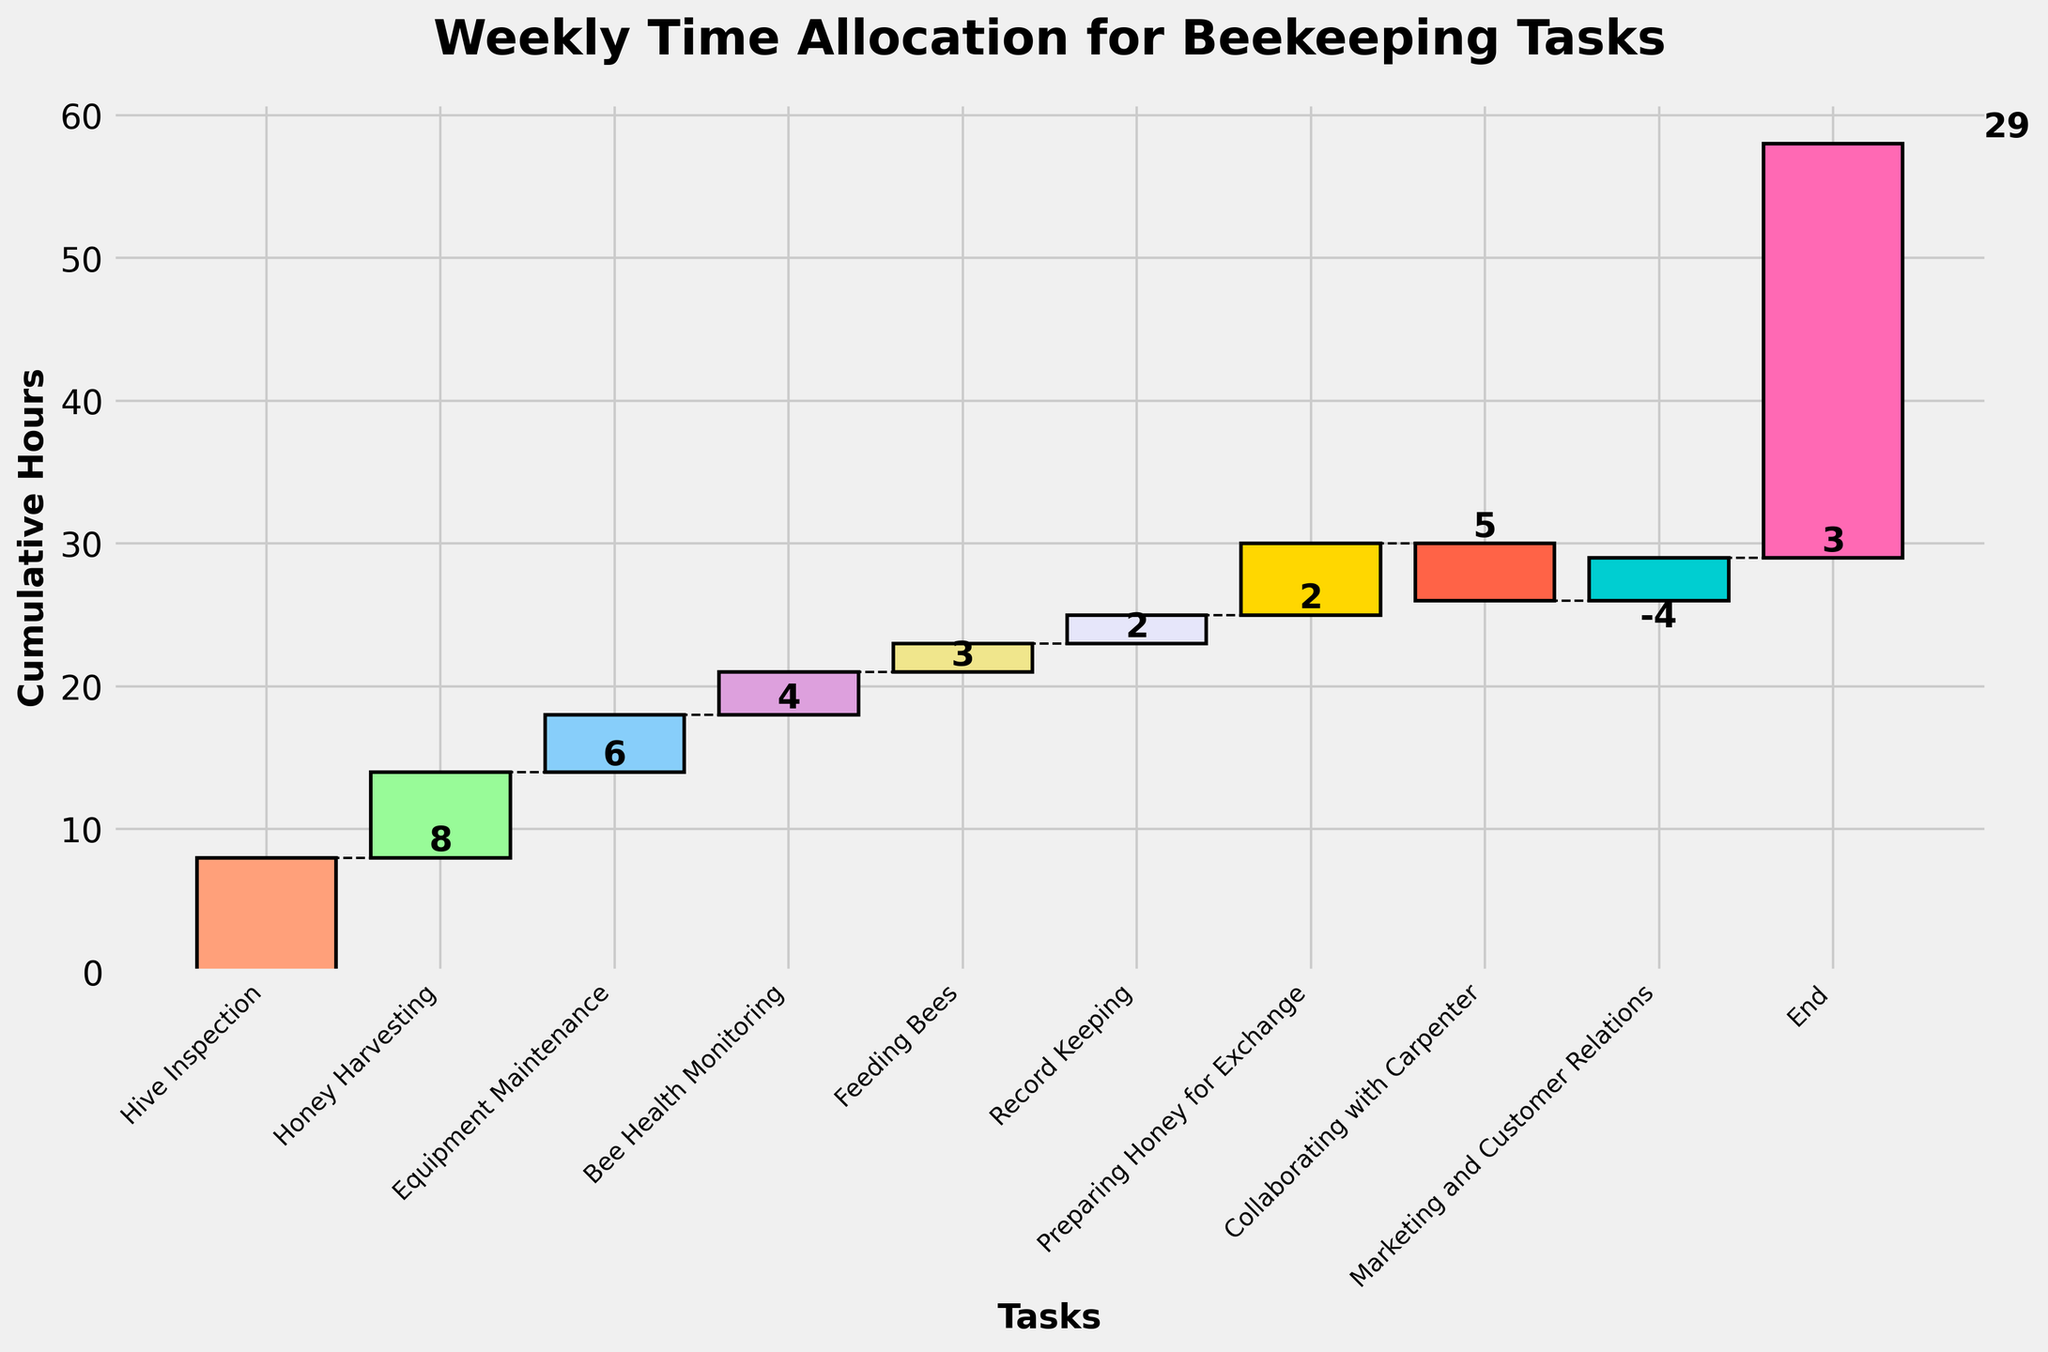What is the title of the chart? The chart's title is prominently displayed at the top of the figure. It is usually formatted in bold and large font.
Answer: Weekly Time Allocation for Beekeeping Tasks How many tasks are listed in the chart? Count the number of unique tasks along the x-axis. Each task represents a data point or category.
Answer: 10 What is the cumulative number of hours spent after Equipment Maintenance? Identify the cumulative hours after the Equipment Maintenance task from the figure. In this case, it involves summing up the hours from Start, Hive Inspection, Honey Harvesting, and Equipment Maintenance.
Answer: 18 Which task has the highest positive number of hours allocated? Look for the task with the highest bar going upward from the previous cumulative total. Compare all upward bars to find the maximum value.
Answer: Hive Inspection How much time is spent collaborating with the carpenter, and what's its impact on the cumulative hours? Identify the specific bar for Collaborating with Carpenter from the x-axis. Note its value and whether it adds to or subtracts from the cumulative total.
Answer: -4 hours, decreases the cumulative hours What is the total number of hours spent on Honey Harvesting and Feeding Bees combined? Add the hours spent on Honey Harvesting and Feeding Bees as shown in the figure. Honey Harvesting is 6 hours, and Feeding Bees is 2 hours.
Answer: 8 hours Is the time spent on Record Keeping greater than, equal to, or less than the time spent on Marketing and Customer Relations? Compare the heights of the bars for Record Keeping and Marketing and Customer Relations. Record Keeping has a value of 2 hours and Marketing and Customer Relations has a value of 3 hours.
Answer: Less than What is the total cumulative time at the end of the week? The final cumulative value at the end of the chart indicates the total hours. It accounts for all positive and negative time allocations throughout the week.
Answer: 29 hours How do the hours allocated to Preparing Honey for Exchange compare to Bee Health Monitoring? Note the height of the bars for Preparing Honey for Exchange and Bee Health Monitoring. Preparing Honey for Exchange has 5 hours, and Bee Health Monitoring has 3 hours, so 5 is greater than 3.
Answer: Preparing Honey for Exchange has more hours How does the cumulative hours change between Hive Inspection and Honey Harvesting? Calculate the cumulative hours after Hive Inspection and then show how it changes with the addition of the Honey Harvesting hours. Hive Inspection has 8 hours, Honey Harvesting adds 6 hours on top of that.
Answer: Increases by 6 hours 